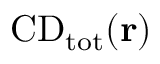<formula> <loc_0><loc_0><loc_500><loc_500>{ C D } _ { \mathrm { t o t } } ( { r } )</formula> 